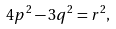Convert formula to latex. <formula><loc_0><loc_0><loc_500><loc_500>4 p ^ { 2 } - 3 q ^ { 2 } = r ^ { 2 } ,</formula> 